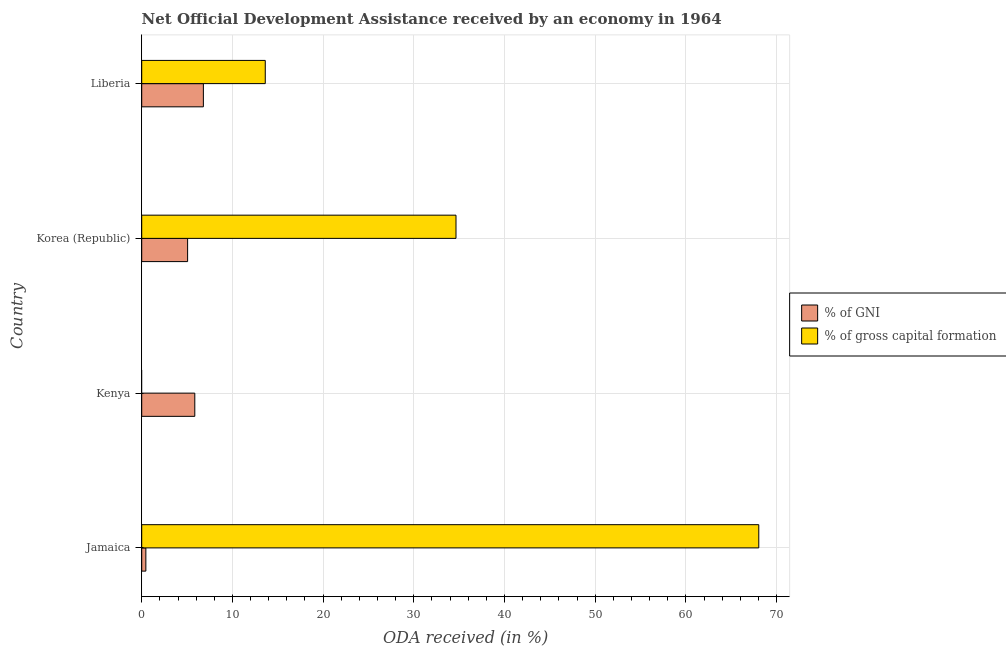How many different coloured bars are there?
Provide a short and direct response. 2. Are the number of bars per tick equal to the number of legend labels?
Give a very brief answer. No. Are the number of bars on each tick of the Y-axis equal?
Make the answer very short. No. How many bars are there on the 1st tick from the bottom?
Your answer should be very brief. 2. What is the label of the 1st group of bars from the top?
Your answer should be very brief. Liberia. What is the oda received as percentage of gross capital formation in Jamaica?
Provide a succinct answer. 68.04. Across all countries, what is the maximum oda received as percentage of gross capital formation?
Your response must be concise. 68.04. Across all countries, what is the minimum oda received as percentage of gni?
Provide a short and direct response. 0.46. In which country was the oda received as percentage of gni maximum?
Offer a very short reply. Liberia. What is the total oda received as percentage of gross capital formation in the graph?
Offer a terse response. 116.32. What is the difference between the oda received as percentage of gni in Jamaica and that in Kenya?
Ensure brevity in your answer.  -5.4. What is the difference between the oda received as percentage of gni in Kenya and the oda received as percentage of gross capital formation in Liberia?
Offer a very short reply. -7.77. What is the average oda received as percentage of gross capital formation per country?
Give a very brief answer. 29.08. What is the difference between the oda received as percentage of gni and oda received as percentage of gross capital formation in Liberia?
Offer a terse response. -6.83. In how many countries, is the oda received as percentage of gni greater than 40 %?
Provide a succinct answer. 0. What is the ratio of the oda received as percentage of gni in Jamaica to that in Korea (Republic)?
Provide a succinct answer. 0.09. Is the oda received as percentage of gross capital formation in Jamaica less than that in Liberia?
Provide a succinct answer. No. Is the difference between the oda received as percentage of gross capital formation in Jamaica and Liberia greater than the difference between the oda received as percentage of gni in Jamaica and Liberia?
Keep it short and to the point. Yes. What is the difference between the highest and the second highest oda received as percentage of gni?
Provide a short and direct response. 0.94. What is the difference between the highest and the lowest oda received as percentage of gross capital formation?
Your response must be concise. 68.04. Is the sum of the oda received as percentage of gross capital formation in Korea (Republic) and Liberia greater than the maximum oda received as percentage of gni across all countries?
Provide a short and direct response. Yes. How many bars are there?
Make the answer very short. 7. Are all the bars in the graph horizontal?
Provide a short and direct response. Yes. How many countries are there in the graph?
Offer a terse response. 4. Does the graph contain grids?
Your answer should be very brief. Yes. How are the legend labels stacked?
Your response must be concise. Vertical. What is the title of the graph?
Provide a succinct answer. Net Official Development Assistance received by an economy in 1964. Does "Public funds" appear as one of the legend labels in the graph?
Ensure brevity in your answer.  No. What is the label or title of the X-axis?
Offer a very short reply. ODA received (in %). What is the label or title of the Y-axis?
Keep it short and to the point. Country. What is the ODA received (in %) in % of GNI in Jamaica?
Your answer should be compact. 0.46. What is the ODA received (in %) of % of gross capital formation in Jamaica?
Offer a terse response. 68.04. What is the ODA received (in %) in % of GNI in Kenya?
Your answer should be compact. 5.85. What is the ODA received (in %) of % of gross capital formation in Kenya?
Ensure brevity in your answer.  0. What is the ODA received (in %) in % of GNI in Korea (Republic)?
Offer a very short reply. 5.06. What is the ODA received (in %) of % of gross capital formation in Korea (Republic)?
Offer a terse response. 34.65. What is the ODA received (in %) in % of GNI in Liberia?
Keep it short and to the point. 6.8. What is the ODA received (in %) in % of gross capital formation in Liberia?
Make the answer very short. 13.62. Across all countries, what is the maximum ODA received (in %) of % of GNI?
Ensure brevity in your answer.  6.8. Across all countries, what is the maximum ODA received (in %) in % of gross capital formation?
Provide a succinct answer. 68.04. Across all countries, what is the minimum ODA received (in %) in % of GNI?
Make the answer very short. 0.46. What is the total ODA received (in %) in % of GNI in the graph?
Provide a succinct answer. 18.17. What is the total ODA received (in %) in % of gross capital formation in the graph?
Give a very brief answer. 116.32. What is the difference between the ODA received (in %) of % of GNI in Jamaica and that in Kenya?
Your response must be concise. -5.4. What is the difference between the ODA received (in %) in % of GNI in Jamaica and that in Korea (Republic)?
Keep it short and to the point. -4.6. What is the difference between the ODA received (in %) in % of gross capital formation in Jamaica and that in Korea (Republic)?
Make the answer very short. 33.39. What is the difference between the ODA received (in %) of % of GNI in Jamaica and that in Liberia?
Your answer should be compact. -6.34. What is the difference between the ODA received (in %) in % of gross capital formation in Jamaica and that in Liberia?
Provide a short and direct response. 54.42. What is the difference between the ODA received (in %) of % of GNI in Kenya and that in Korea (Republic)?
Provide a short and direct response. 0.79. What is the difference between the ODA received (in %) of % of GNI in Kenya and that in Liberia?
Give a very brief answer. -0.95. What is the difference between the ODA received (in %) of % of GNI in Korea (Republic) and that in Liberia?
Keep it short and to the point. -1.74. What is the difference between the ODA received (in %) in % of gross capital formation in Korea (Republic) and that in Liberia?
Your answer should be compact. 21.03. What is the difference between the ODA received (in %) in % of GNI in Jamaica and the ODA received (in %) in % of gross capital formation in Korea (Republic)?
Provide a succinct answer. -34.2. What is the difference between the ODA received (in %) of % of GNI in Jamaica and the ODA received (in %) of % of gross capital formation in Liberia?
Provide a short and direct response. -13.17. What is the difference between the ODA received (in %) in % of GNI in Kenya and the ODA received (in %) in % of gross capital formation in Korea (Republic)?
Your response must be concise. -28.8. What is the difference between the ODA received (in %) of % of GNI in Kenya and the ODA received (in %) of % of gross capital formation in Liberia?
Provide a succinct answer. -7.77. What is the difference between the ODA received (in %) of % of GNI in Korea (Republic) and the ODA received (in %) of % of gross capital formation in Liberia?
Ensure brevity in your answer.  -8.56. What is the average ODA received (in %) of % of GNI per country?
Your response must be concise. 4.54. What is the average ODA received (in %) of % of gross capital formation per country?
Provide a succinct answer. 29.08. What is the difference between the ODA received (in %) of % of GNI and ODA received (in %) of % of gross capital formation in Jamaica?
Provide a short and direct response. -67.58. What is the difference between the ODA received (in %) in % of GNI and ODA received (in %) in % of gross capital formation in Korea (Republic)?
Give a very brief answer. -29.59. What is the difference between the ODA received (in %) in % of GNI and ODA received (in %) in % of gross capital formation in Liberia?
Provide a succinct answer. -6.83. What is the ratio of the ODA received (in %) of % of GNI in Jamaica to that in Kenya?
Your answer should be compact. 0.08. What is the ratio of the ODA received (in %) in % of GNI in Jamaica to that in Korea (Republic)?
Keep it short and to the point. 0.09. What is the ratio of the ODA received (in %) of % of gross capital formation in Jamaica to that in Korea (Republic)?
Provide a short and direct response. 1.96. What is the ratio of the ODA received (in %) of % of GNI in Jamaica to that in Liberia?
Your answer should be very brief. 0.07. What is the ratio of the ODA received (in %) in % of gross capital formation in Jamaica to that in Liberia?
Provide a succinct answer. 4.99. What is the ratio of the ODA received (in %) in % of GNI in Kenya to that in Korea (Republic)?
Make the answer very short. 1.16. What is the ratio of the ODA received (in %) of % of GNI in Kenya to that in Liberia?
Your answer should be very brief. 0.86. What is the ratio of the ODA received (in %) of % of GNI in Korea (Republic) to that in Liberia?
Ensure brevity in your answer.  0.74. What is the ratio of the ODA received (in %) in % of gross capital formation in Korea (Republic) to that in Liberia?
Your answer should be very brief. 2.54. What is the difference between the highest and the second highest ODA received (in %) of % of GNI?
Give a very brief answer. 0.95. What is the difference between the highest and the second highest ODA received (in %) of % of gross capital formation?
Your response must be concise. 33.39. What is the difference between the highest and the lowest ODA received (in %) of % of GNI?
Offer a terse response. 6.34. What is the difference between the highest and the lowest ODA received (in %) in % of gross capital formation?
Offer a terse response. 68.04. 